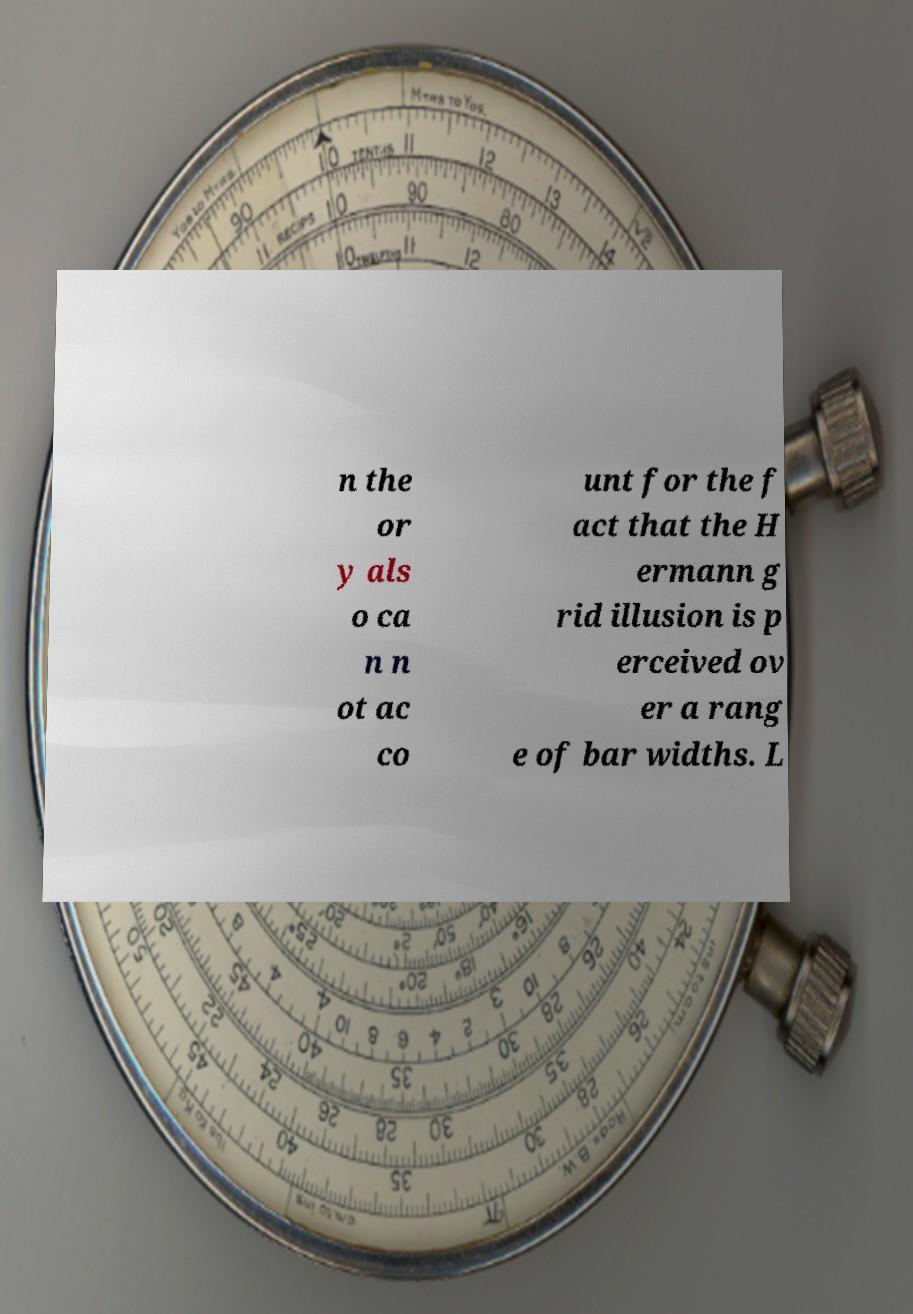For documentation purposes, I need the text within this image transcribed. Could you provide that? n the or y als o ca n n ot ac co unt for the f act that the H ermann g rid illusion is p erceived ov er a rang e of bar widths. L 